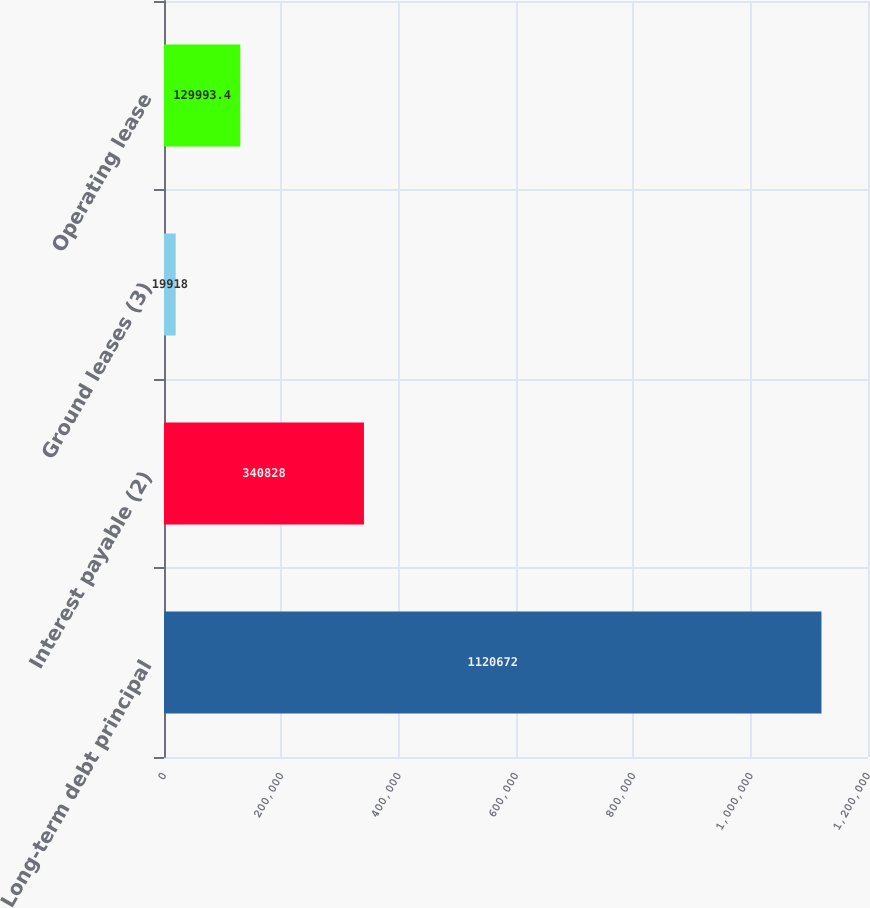<chart> <loc_0><loc_0><loc_500><loc_500><bar_chart><fcel>Long-term debt principal<fcel>Interest payable (2)<fcel>Ground leases (3)<fcel>Operating lease<nl><fcel>1.12067e+06<fcel>340828<fcel>19918<fcel>129993<nl></chart> 